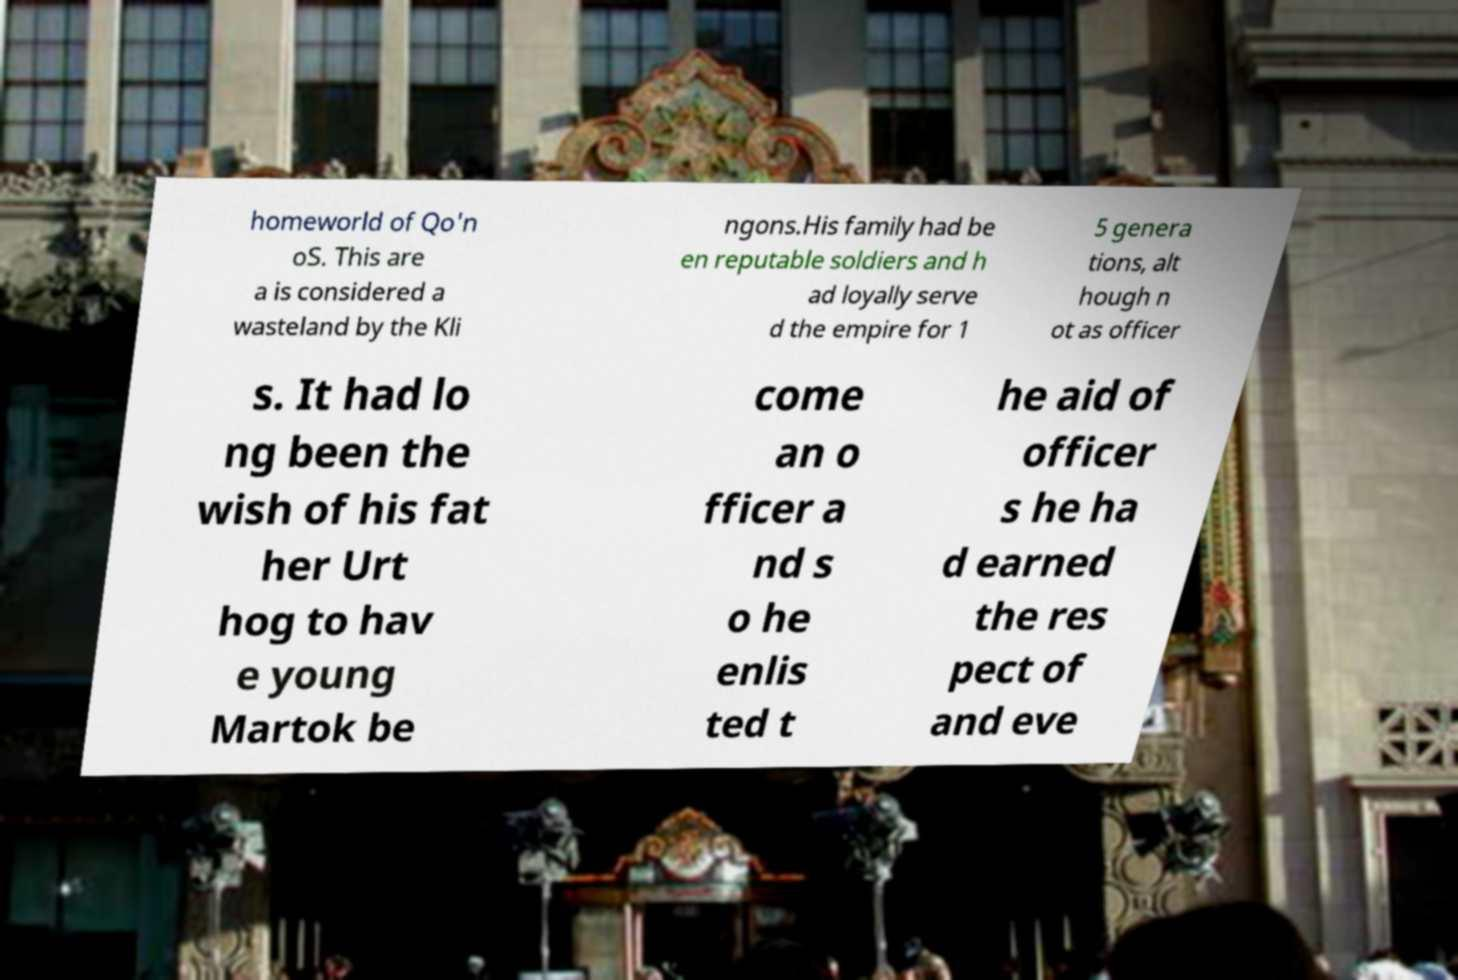I need the written content from this picture converted into text. Can you do that? homeworld of Qo'n oS. This are a is considered a wasteland by the Kli ngons.His family had be en reputable soldiers and h ad loyally serve d the empire for 1 5 genera tions, alt hough n ot as officer s. It had lo ng been the wish of his fat her Urt hog to hav e young Martok be come an o fficer a nd s o he enlis ted t he aid of officer s he ha d earned the res pect of and eve 